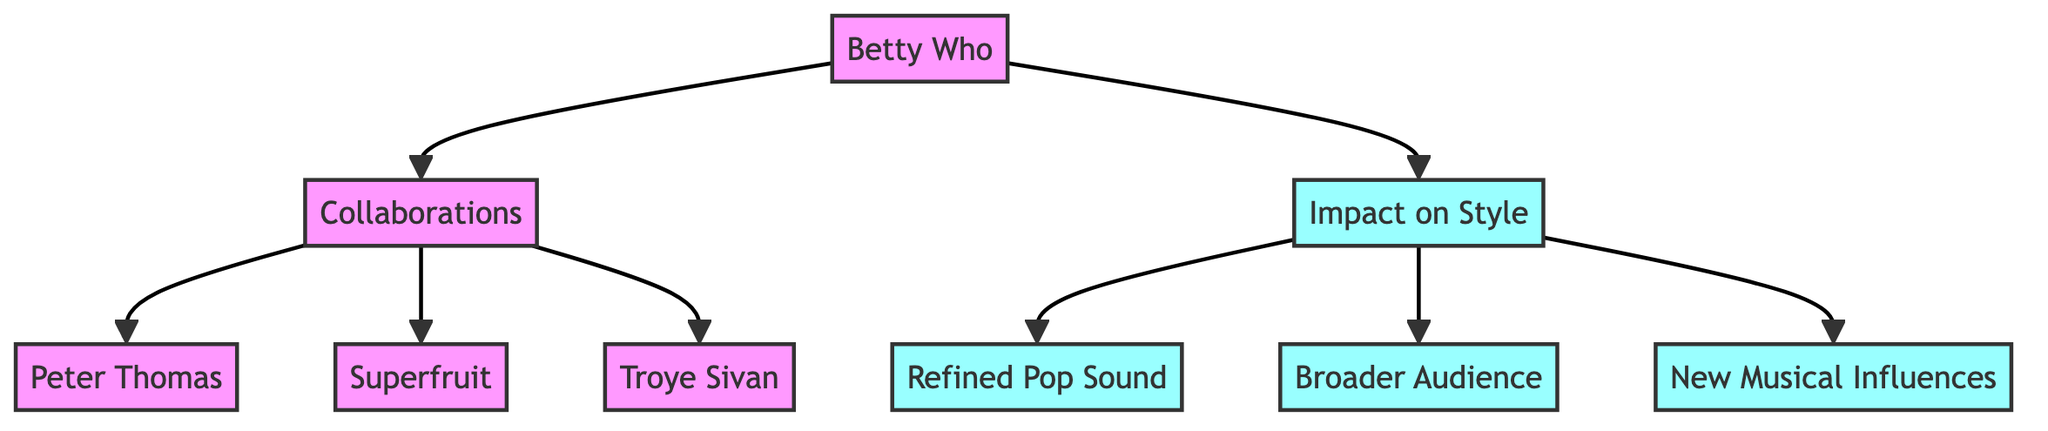What are the two main categories represented in the diagram? The diagram features two main categories indicated by "Collaborations" and "Impact on Style," which are branched under "Betty Who."
Answer: Collaborations, Impact on Style How many artists has Betty Who collaborated with according to the diagram? The diagram lists three collaborators: Peter Thomas, Superfruit, and Troye Sivan, which indicates there are three artists.
Answer: 3 What is one direct impact of Betty Who's collaborations on her music style? The diagram shows several impacts, including "Refined Pop Sound," "Broader Audience," and "New Musical Influences," thus any of these impacts can be stated as a direct result.
Answer: Refined Pop Sound Which artist is connected to the collaboration node besides Peter Thomas? The diagram lists two additional collaborators under "Collaborations": Superfruit and Troye Sivan, indicating multiple connections. The answer must include one of the names, as it asks for an artist besides Peter Thomas.
Answer: Superfruit What is the relationship between the collaboration with Troye Sivan and the impact on style? The diagram illustrates that collaborating with Troye Sivan directly connects to the related impacts on Betty Who's style, specifically contributing to the impact on her music style, thus highlighting the influence of that collaboration.
Answer: Impact on Style Which category leads to the creation of a "Broader Audience"? The flowchart shows that "Collaborations" leads to various impacts on style, one of which is specifically noted as contributing to a "Broader Audience." Therefore, the answer must specify which category has this pathway.
Answer: Collaborations How many impacts are listed under "Impact on Style"? The diagram mentions three impacts: "Refined Pop Sound," "Broader Audience," and "New Musical Influences," making the total count three.
Answer: 3 What is the visual representation of Betty Who in the diagram? In the diagram, Betty Who is represented as the initial node, indicating her as the central figure from which collaborations and impacts radiate, thus visually emphasizing her role and influence.
Answer: Betty Who 